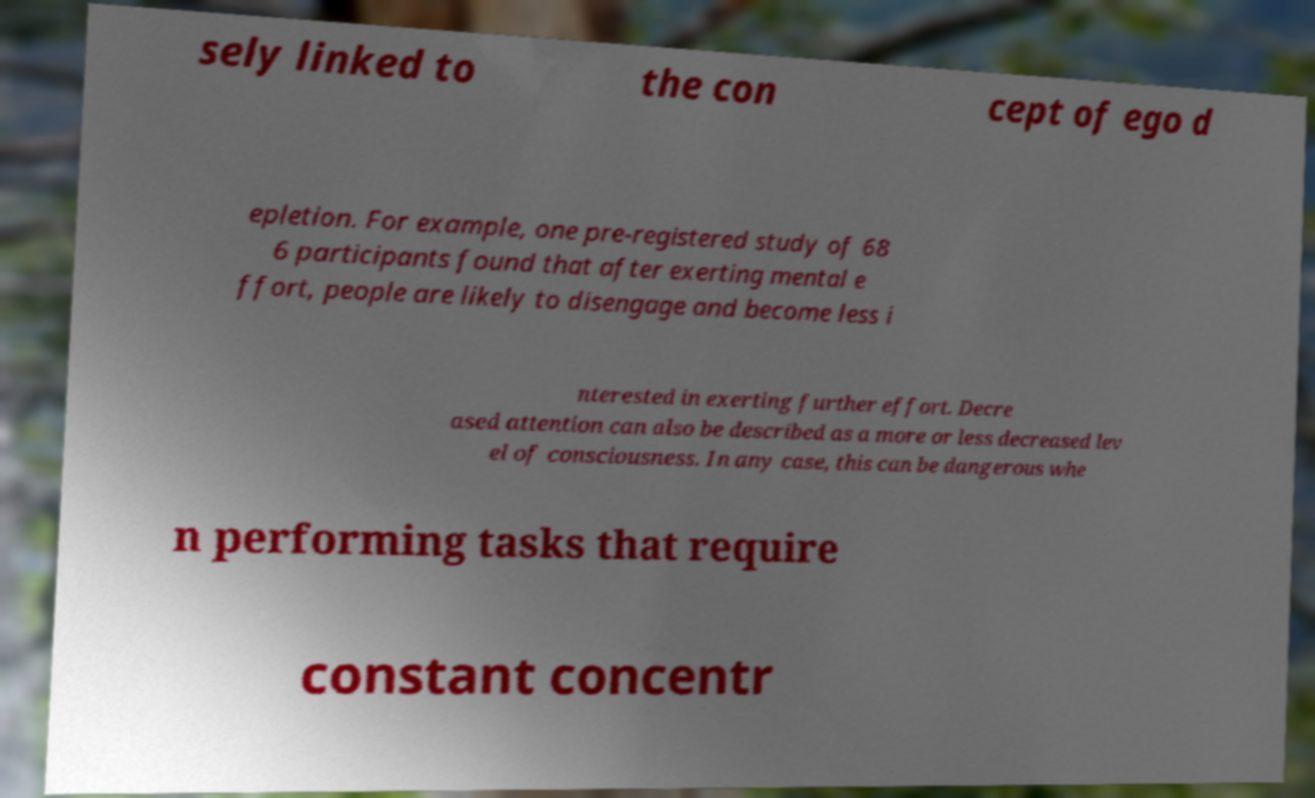Please identify and transcribe the text found in this image. sely linked to the con cept of ego d epletion. For example, one pre-registered study of 68 6 participants found that after exerting mental e ffort, people are likely to disengage and become less i nterested in exerting further effort. Decre ased attention can also be described as a more or less decreased lev el of consciousness. In any case, this can be dangerous whe n performing tasks that require constant concentr 